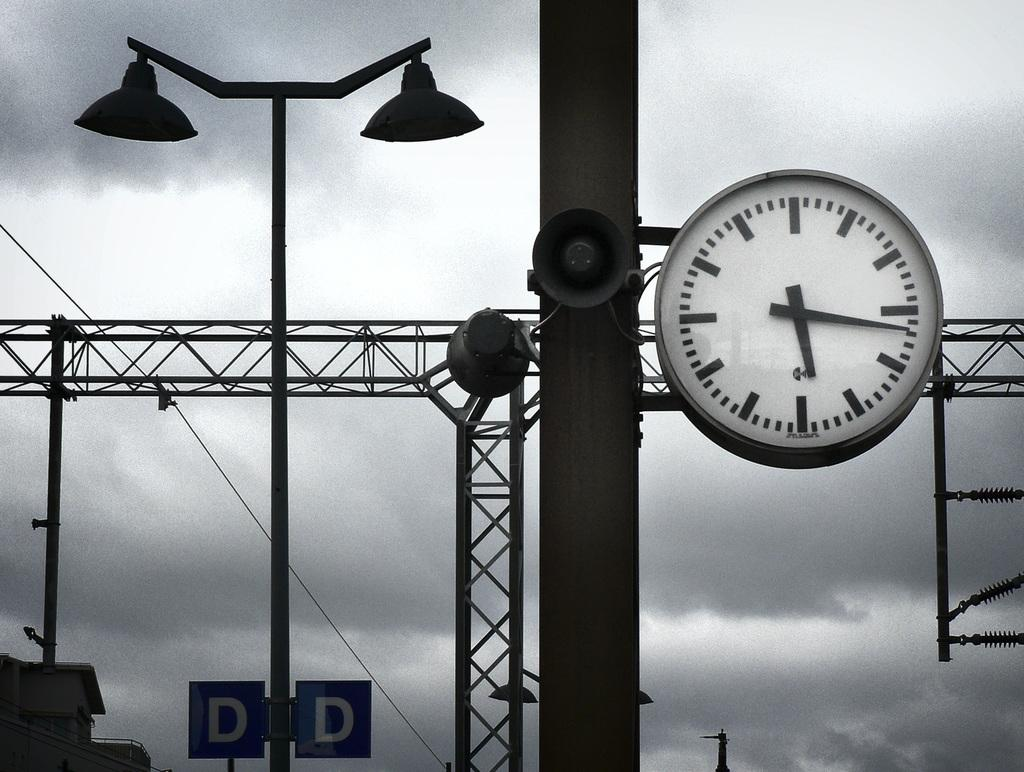<image>
Relay a brief, clear account of the picture shown. a street pole with the letters DD on them 